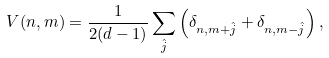Convert formula to latex. <formula><loc_0><loc_0><loc_500><loc_500>V ( n , m ) = \frac { 1 } { 2 ( d - 1 ) } \sum _ { \hat { j } } \left ( \delta _ { n , m + \hat { j } } + \delta _ { n , m - \hat { j } } \right ) ,</formula> 